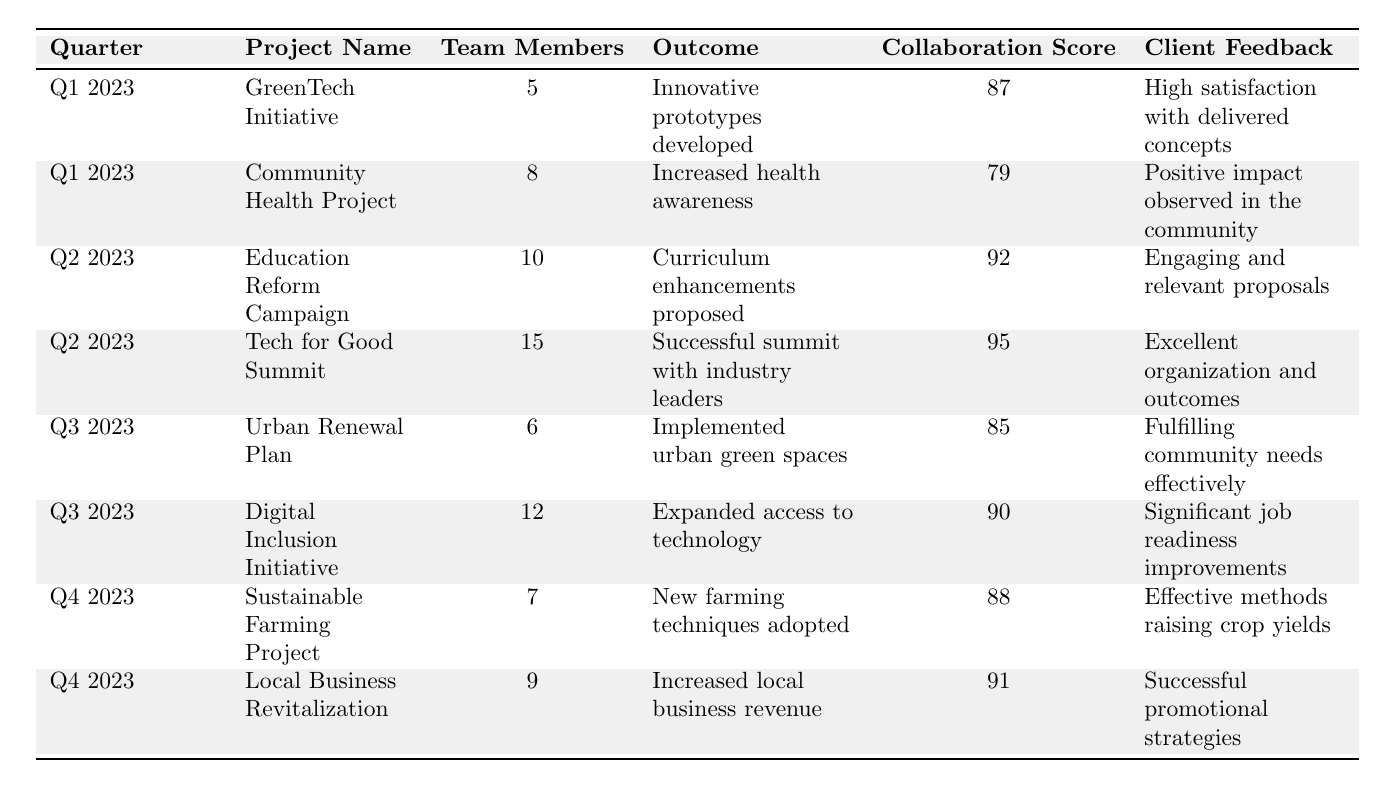What was the collaboration score for the Tech for Good Summit? The collaboration score for the Tech for Good Summit can be found directly in the table, where it lists the project and associated scores. It shows a score of 95 for that project.
Answer: 95 Which project had the highest collaboration score in Q2 2023? In Q2 2023, there are two projects: Education Reform Campaign with a score of 92 and Tech for Good Summit with a score of 95. Comparing these, the Tech for Good Summit has the highest score.
Answer: Tech for Good Summit How many total team members were involved in the projects during Q1 2023? In Q1 2023, there are two projects: GreenTech Initiative with 5 members and Community Health Project with 8 members. Adding them together gives 5 + 8 = 13 total team members.
Answer: 13 Did the Digital Inclusion Initiative receive a higher collaboration score than the Urban Renewal Plan? The Digital Inclusion Initiative received a score of 90, and the Urban Renewal Plan received a score of 85. Since 90 is greater than 85, the answer is yes, it received a higher score.
Answer: Yes What is the average collaboration score for all projects listed? To find the average, sum all collaboration scores (87 + 79 + 92 + 95 + 85 + 90 + 88 + 91 = 717) and divide by the total number of projects (8). The average is 717/8 = 89.625, which can be rounded and reported as 89.6.
Answer: 89.6 Which quarter had the project with the lowest collaboration score? Looking at the table, the lowest collaboration score among the projects is 79 from the Community Health Project, which is in Q1 2023. Therefore, Q1 2023 has the project with the lowest score.
Answer: Q1 2023 How many projects involved more than 10 team members in total? Looking through the table, the Tech for Good Summit had 15 team members, and the Education Reform Campaign had 10. Since only the Tech for Good Summit involved more than 10 members, there is only one project meeting the criterion.
Answer: 1 Which project had a client feedback indicating a positive impact on the community? The Community Health Project was noted for having "Positive impact observed in the community" as its client feedback. No other project made a similar claim.
Answer: Community Health Project What was the overall trend in collaboration scores from Q1 to Q4? By comparing the scores for each quarter (Q1: 87, 79; Q2: 92, 95; Q3: 85, 90; Q4: 88, 91), we observe that Q2 has the highest scores, followed by Q4 and then Q3 and Q1 show lower scores. It shows a rise overall from Q1 to Q2, a slight drop to Q3, and then a rise to Q4.
Answer: Mixed trend Is there a project in Q4 2023 that also focused on business? The Local Business Revitalization project in Q4 2023 focused specifically on increasing local business revenue, indicating its focus on business.
Answer: Yes 